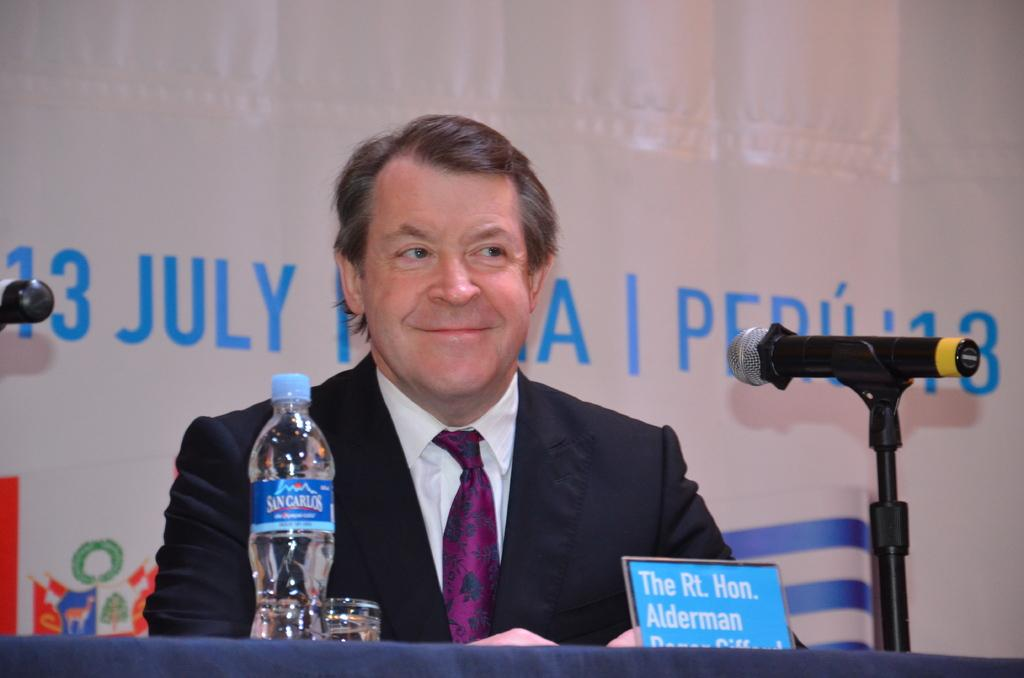What is the person in the image doing? The person is sitting beside a table. What items can be seen on the table? The table contains a water bottle, a glass, a name board, and a mic with a stand. What is written on the name board? The provided facts do not mention the content of the name board. What can be seen on the wall in the background? There is text on a wall in the background. What type of linen is draped over the mic stand in the image? There is no linen present in the image; the mic stand is not covered by any fabric. How many pigs are visible in the image? There are no pigs present in the image. 